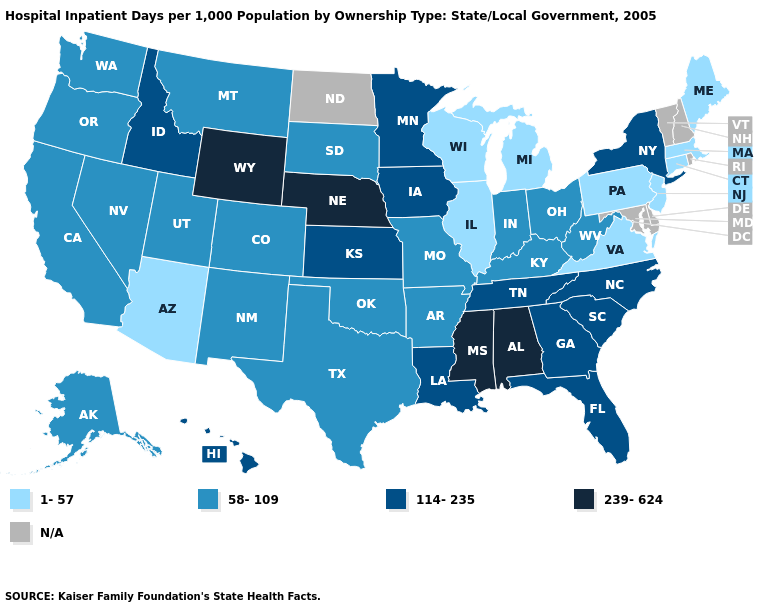Which states have the lowest value in the MidWest?
Short answer required. Illinois, Michigan, Wisconsin. Name the states that have a value in the range 1-57?
Keep it brief. Arizona, Connecticut, Illinois, Maine, Massachusetts, Michigan, New Jersey, Pennsylvania, Virginia, Wisconsin. What is the lowest value in states that border Tennessee?
Keep it brief. 1-57. Does Arizona have the lowest value in the West?
Quick response, please. Yes. What is the lowest value in states that border Indiana?
Write a very short answer. 1-57. What is the value of California?
Short answer required. 58-109. Name the states that have a value in the range N/A?
Keep it brief. Delaware, Maryland, New Hampshire, North Dakota, Rhode Island, Vermont. Which states hav the highest value in the MidWest?
Keep it brief. Nebraska. Name the states that have a value in the range 239-624?
Short answer required. Alabama, Mississippi, Nebraska, Wyoming. Name the states that have a value in the range 58-109?
Give a very brief answer. Alaska, Arkansas, California, Colorado, Indiana, Kentucky, Missouri, Montana, Nevada, New Mexico, Ohio, Oklahoma, Oregon, South Dakota, Texas, Utah, Washington, West Virginia. What is the highest value in the MidWest ?
Write a very short answer. 239-624. What is the value of Missouri?
Answer briefly. 58-109. 